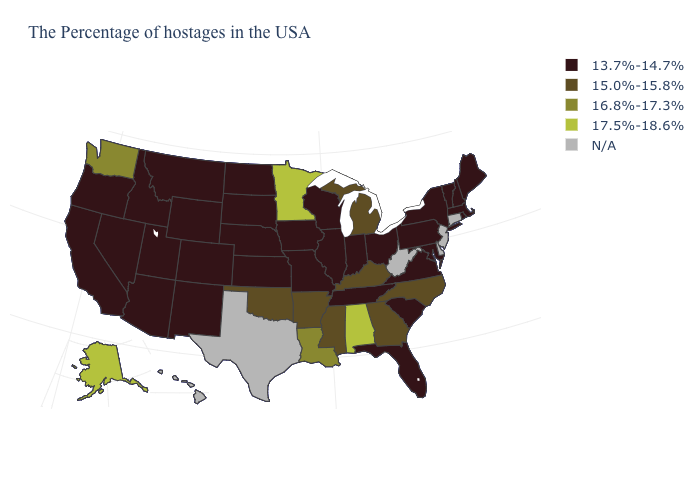What is the value of Massachusetts?
Quick response, please. 13.7%-14.7%. What is the value of Ohio?
Keep it brief. 13.7%-14.7%. Name the states that have a value in the range 17.5%-18.6%?
Concise answer only. Alabama, Minnesota, Alaska. What is the value of Alaska?
Answer briefly. 17.5%-18.6%. Name the states that have a value in the range 17.5%-18.6%?
Keep it brief. Alabama, Minnesota, Alaska. Name the states that have a value in the range N/A?
Keep it brief. Connecticut, New Jersey, Delaware, West Virginia, Texas, Hawaii. Does Kansas have the lowest value in the USA?
Write a very short answer. Yes. Name the states that have a value in the range 17.5%-18.6%?
Be succinct. Alabama, Minnesota, Alaska. Name the states that have a value in the range 16.8%-17.3%?
Concise answer only. Louisiana, Washington. What is the value of Colorado?
Be succinct. 13.7%-14.7%. What is the lowest value in the USA?
Be succinct. 13.7%-14.7%. What is the highest value in the USA?
Quick response, please. 17.5%-18.6%. Does the map have missing data?
Quick response, please. Yes. Name the states that have a value in the range 16.8%-17.3%?
Quick response, please. Louisiana, Washington. 